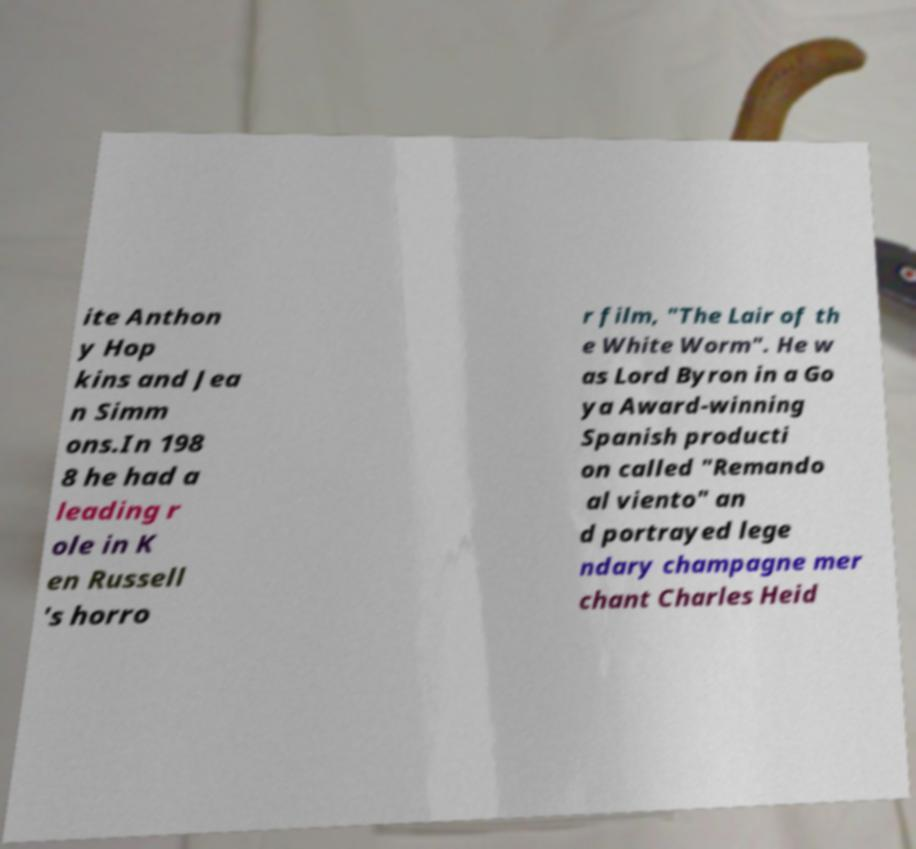I need the written content from this picture converted into text. Can you do that? ite Anthon y Hop kins and Jea n Simm ons.In 198 8 he had a leading r ole in K en Russell 's horro r film, "The Lair of th e White Worm". He w as Lord Byron in a Go ya Award-winning Spanish producti on called "Remando al viento" an d portrayed lege ndary champagne mer chant Charles Heid 